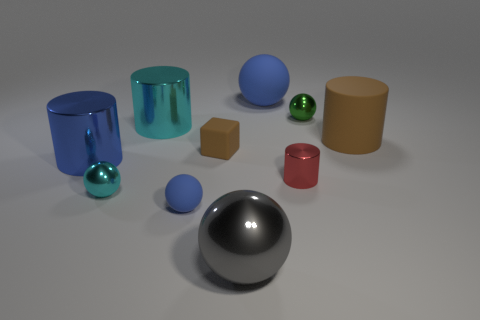Is there another gray sphere made of the same material as the big gray ball?
Provide a succinct answer. No. There is another rubber thing that is the same shape as the red thing; what is its color?
Keep it short and to the point. Brown. Is the number of tiny balls that are on the left side of the big blue cylinder less than the number of small red cylinders behind the small green sphere?
Ensure brevity in your answer.  No. How many other objects are there of the same shape as the tiny blue object?
Ensure brevity in your answer.  4. Are there fewer big metallic balls on the right side of the green sphere than small yellow objects?
Make the answer very short. No. There is a cylinder that is behind the big brown rubber object; what material is it?
Keep it short and to the point. Metal. What number of other things are there of the same size as the red shiny thing?
Provide a succinct answer. 4. Is the number of small green objects less than the number of large green rubber cylinders?
Ensure brevity in your answer.  No. What is the shape of the small red thing?
Offer a terse response. Cylinder. There is a metal cylinder that is in front of the blue metal cylinder; is it the same color as the small matte block?
Offer a terse response. No. 